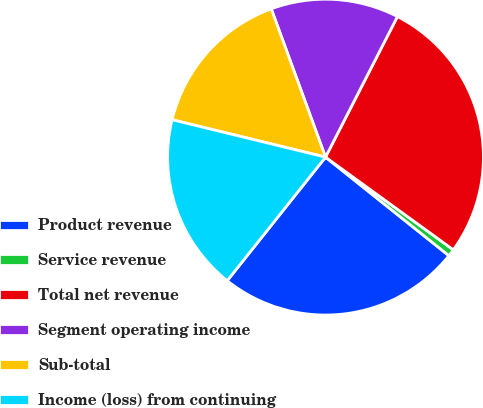Convert chart. <chart><loc_0><loc_0><loc_500><loc_500><pie_chart><fcel>Product revenue<fcel>Service revenue<fcel>Total net revenue<fcel>Segment operating income<fcel>Sub-total<fcel>Income (loss) from continuing<nl><fcel>24.97%<fcel>0.74%<fcel>27.46%<fcel>13.11%<fcel>15.61%<fcel>18.11%<nl></chart> 